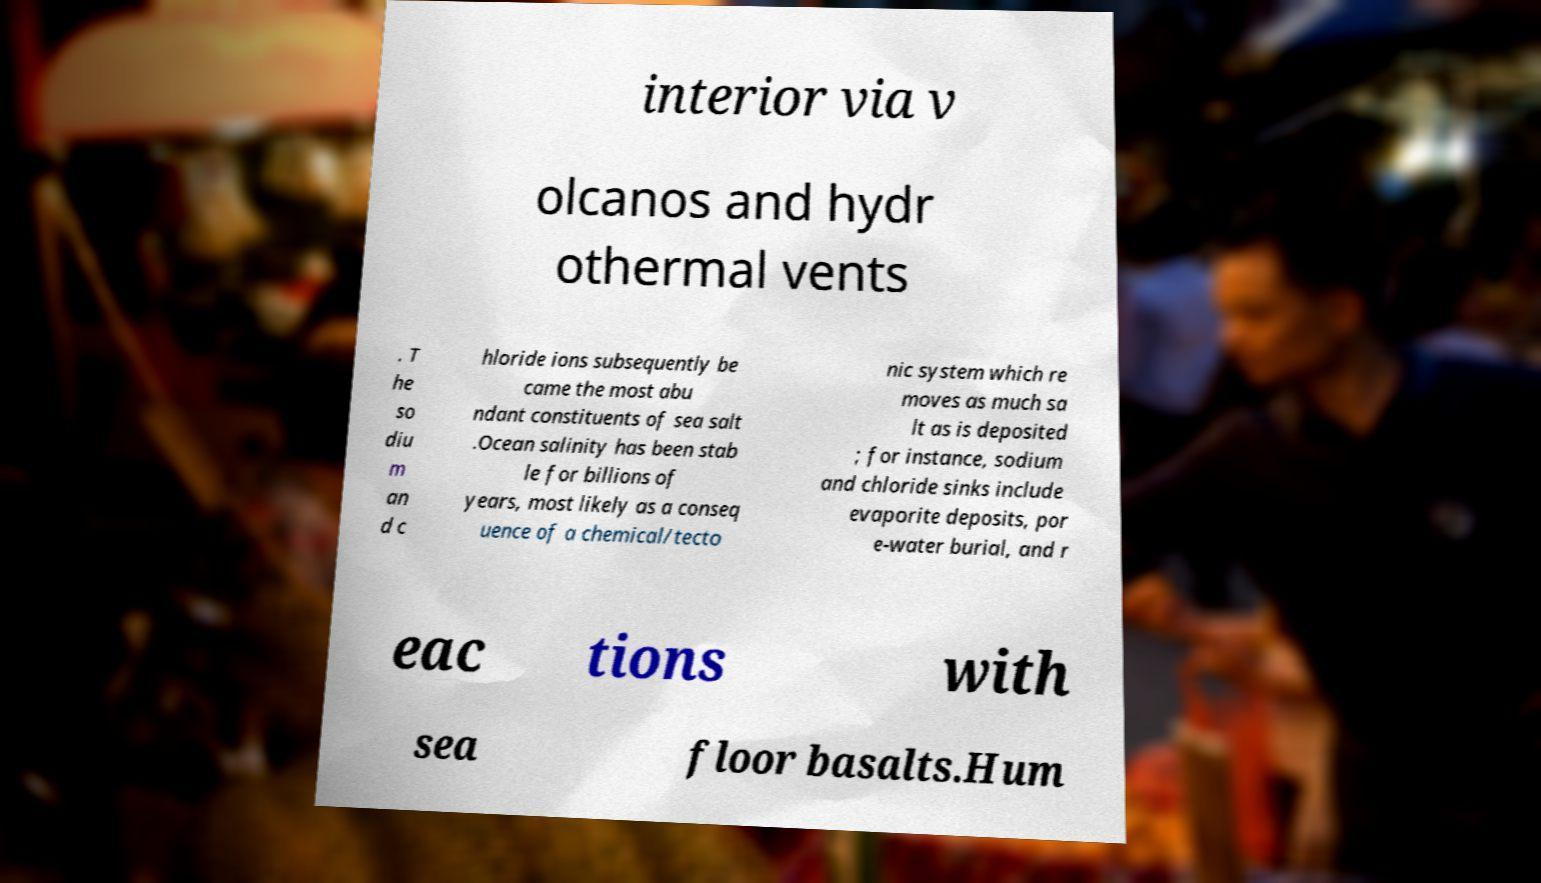What messages or text are displayed in this image? I need them in a readable, typed format. interior via v olcanos and hydr othermal vents . T he so diu m an d c hloride ions subsequently be came the most abu ndant constituents of sea salt .Ocean salinity has been stab le for billions of years, most likely as a conseq uence of a chemical/tecto nic system which re moves as much sa lt as is deposited ; for instance, sodium and chloride sinks include evaporite deposits, por e-water burial, and r eac tions with sea floor basalts.Hum 